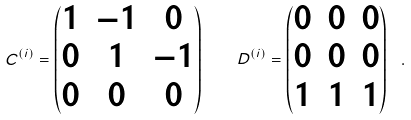<formula> <loc_0><loc_0><loc_500><loc_500>C ^ { ( i ) } = \begin{pmatrix} 1 & - 1 & 0 \\ 0 & 1 & - 1 \\ 0 & 0 & 0 \end{pmatrix} \quad D ^ { ( i ) } = \begin{pmatrix} 0 & 0 & 0 \\ 0 & 0 & 0 \\ 1 & 1 & 1 \end{pmatrix} \ .</formula> 